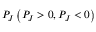Convert formula to latex. <formula><loc_0><loc_0><loc_500><loc_500>P _ { J } \left ( P _ { J } > 0 , P _ { J } < 0 \right )</formula> 